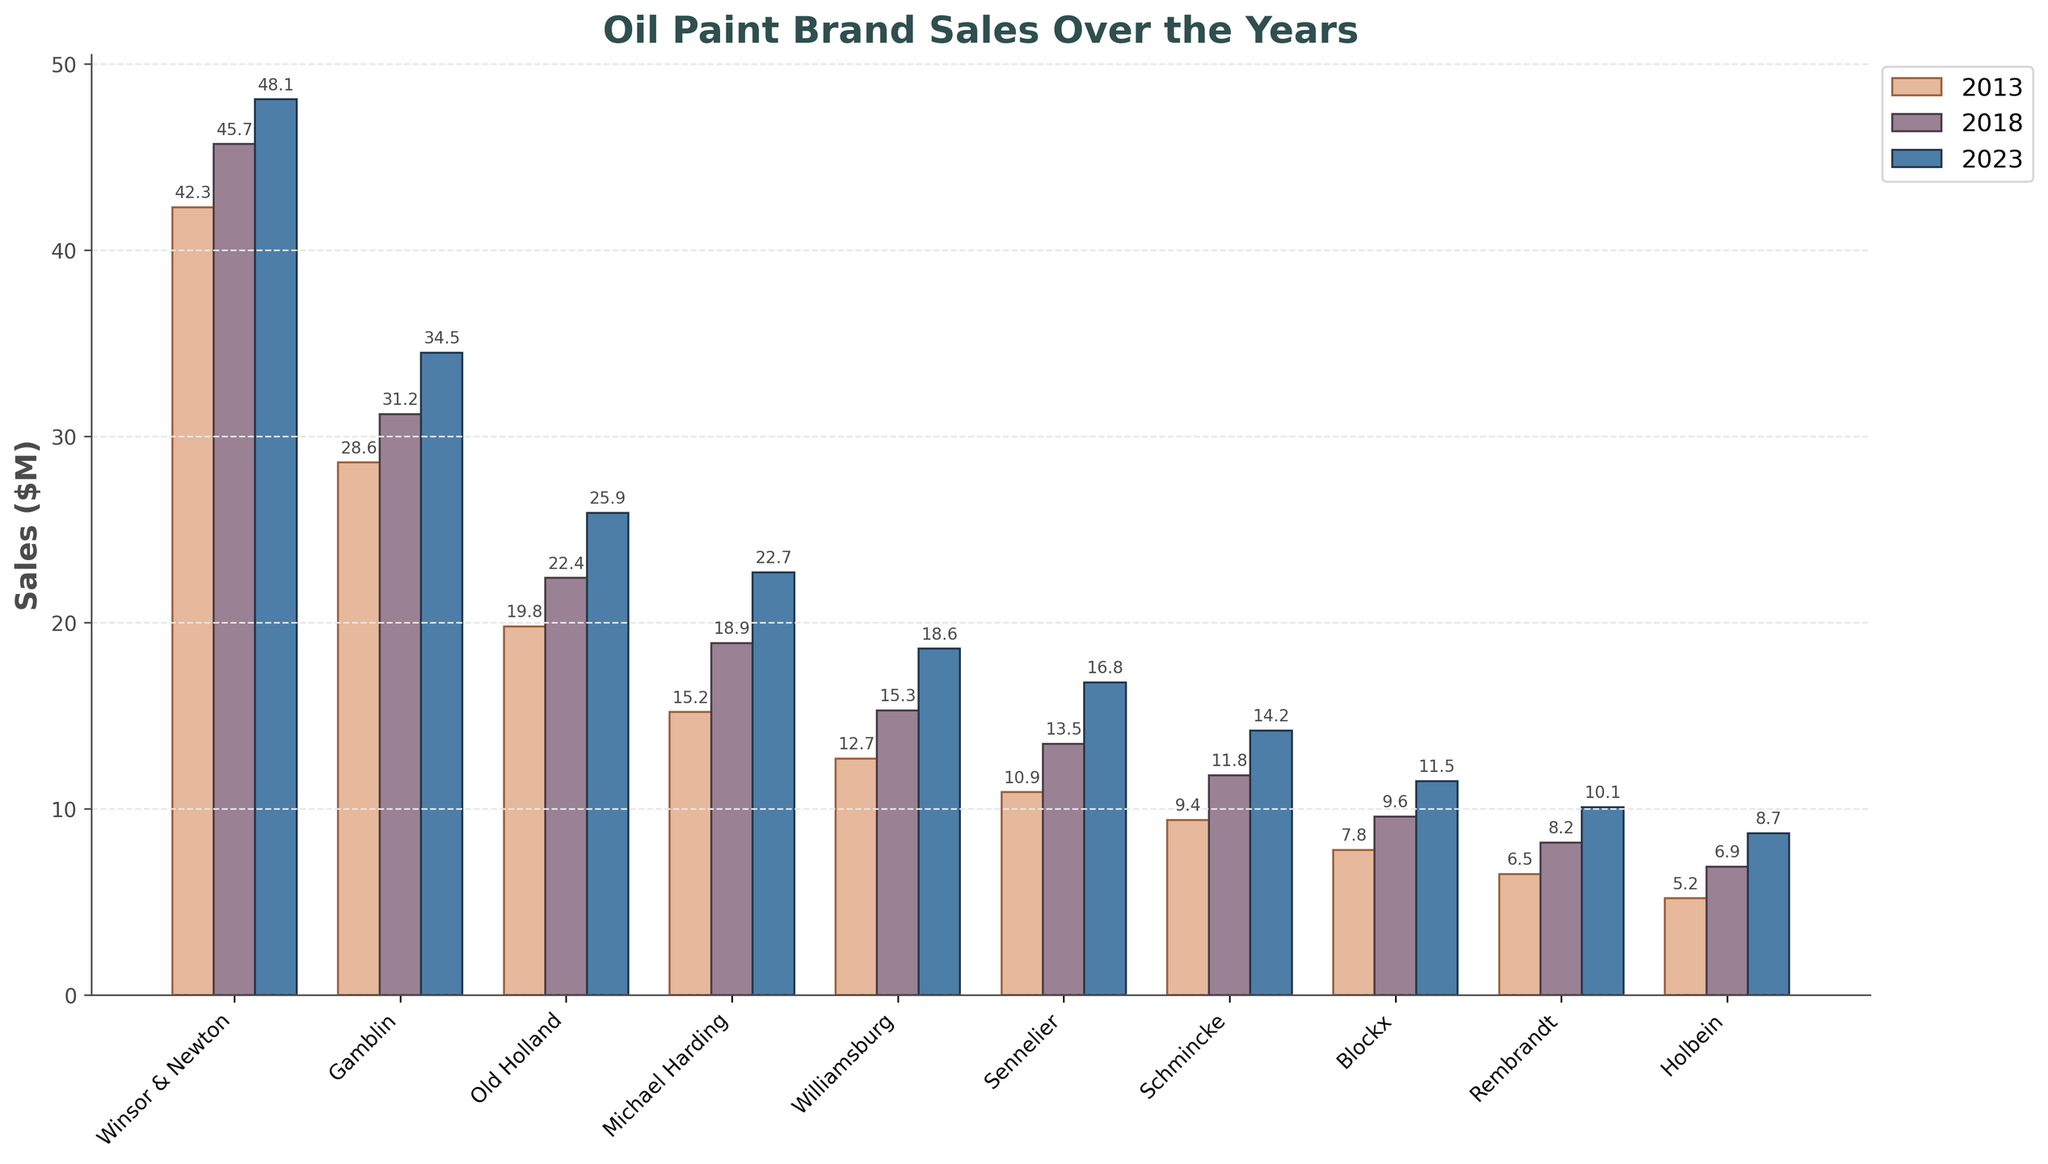What is the difference in sales between Winsor & Newton and Gamblin in 2023? Look at the height of the bars for Winsor & Newton and Gamblin in 2023. Winsor & Newton has sales of 48.1 million dollars, and Gamblin has 34.5 million dollars. Subtract the two values (48.1 - 34.5).
Answer: 13.6 Which brand had the highest increase in sales from 2013 to 2023? Check the difference in height of the bars for each brand between 2013 and 2023. For Winsor & Newton, the increase is 48.1 - 42.3 = 5.8 million dollars. Repeat for all brands. The largest increase is for Old Holland, which went from 19.8 to 25.9 (25.9 - 19.8 = 6.1 million dollars).
Answer: Old Holland Between which consecutive years (2013-2018 or 2018-2023) did Michael Harding see a bigger increase in sales? Compare the height of Michael Harding's bars for 2013, 2018, and 2023. From 2013 to 2018, the increase is 18.9 - 15.2 = 3.7 million dollars. From 2018 to 2023, the increase is 22.7 - 18.9 = 3.8 million dollars.
Answer: 2018-2023 What is the total sales for Rembrandt across all three years shown? Add the height of the bars for Rembrandt for 2013, 2018, and 2023. The values are 6.5, 8.2, and 10.1. Summing them up, 6.5 + 8.2 + 10.1 = 24.8 million dollars.
Answer: 24.8 Which brand had the lowest sales in 2013? Identify the shortest bar for 2013. The bar for Holbein is the shortest, indicating it had the lowest sales. The sales figure for Holbein in 2013 is 5.2 million dollars.
Answer: Holbein What’s the average sales figure for all brands in 2023? Sum the sales figures for all brands in 2023 and divide by the number of brands. The numbers are 48.1, 34.5, 25.9, 22.7, 18.6, 16.8, 14.2, 11.5, 10.1, and 8.7. Summing them gives 211.1. Divide by 10 (number of brands) to get the average. 211.1 / 10 = 21.11 million dollars.
Answer: 21.11 Which brand showed the smallest change in sales from 2018 to 2023? Calculate the change in sales for each brand from 2018 to 2023. The changes are: Winsor & Newton (2.4), Gamblin (3.3), Old Holland (3.5), Michael Harding (3.8), Williamsburg (3.3), Sennelier (3.3), Schmincke (2.4), Blockx (1.9), Rembrandt (1.9), Holbein (1.8). Blockx and Rembrandt tie for the smallest change.
Answer: Blockx, Rembrandt 